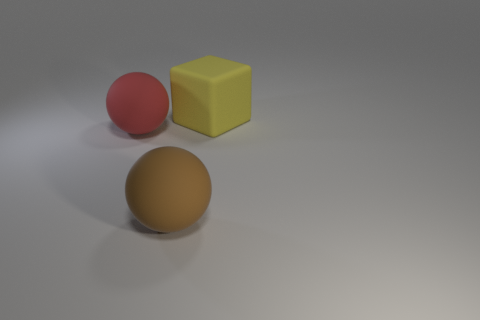Subtract 1 balls. How many balls are left? 1 Add 2 big rubber cubes. How many objects exist? 5 Subtract all purple spheres. Subtract all brown cylinders. How many spheres are left? 2 Subtract all balls. How many objects are left? 1 Subtract all red blocks. How many brown balls are left? 1 Subtract all big green shiny things. Subtract all large rubber objects. How many objects are left? 0 Add 3 big rubber spheres. How many big rubber spheres are left? 5 Add 1 metallic balls. How many metallic balls exist? 1 Subtract 1 red balls. How many objects are left? 2 